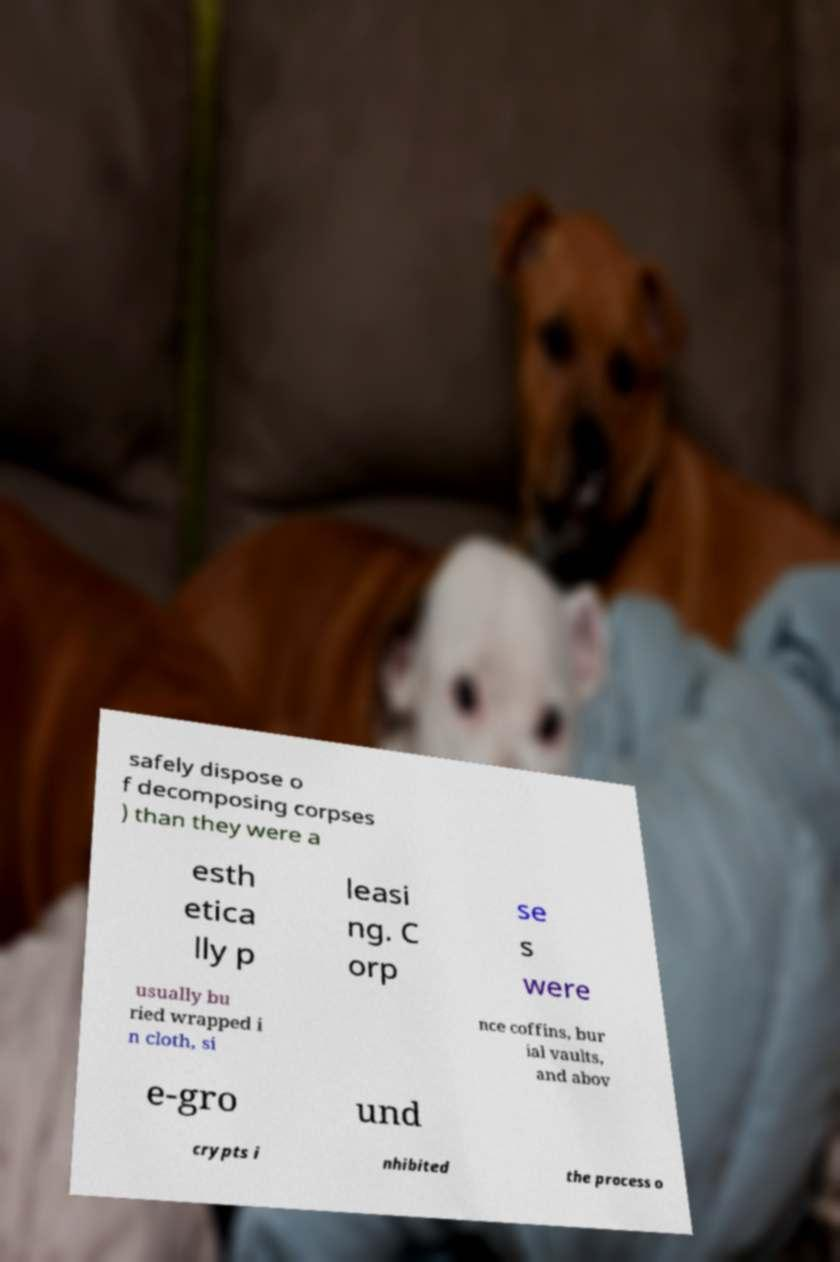Please identify and transcribe the text found in this image. safely dispose o f decomposing corpses ) than they were a esth etica lly p leasi ng. C orp se s were usually bu ried wrapped i n cloth, si nce coffins, bur ial vaults, and abov e-gro und crypts i nhibited the process o 